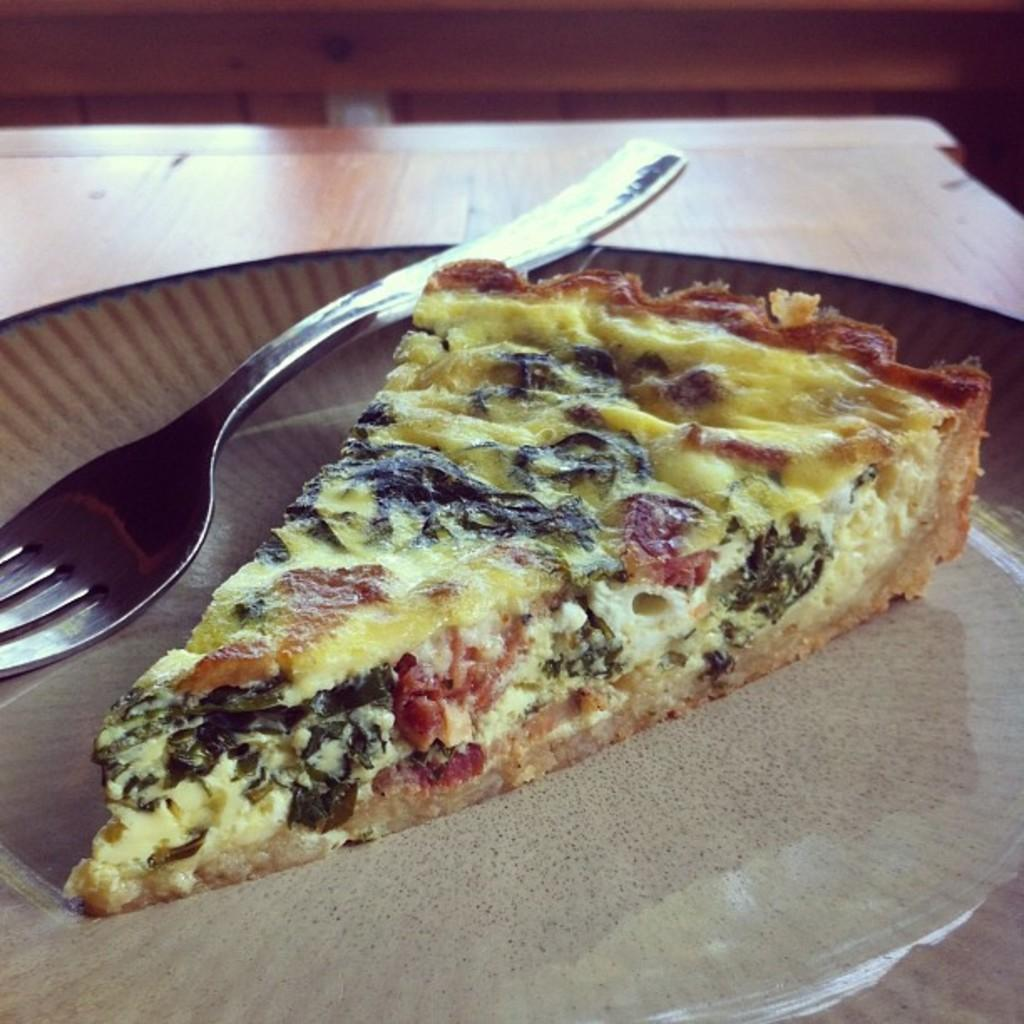What type of food is visible in the image? There is a slice of pizza in the image. What utensil can be seen on a plate in the image? There is a fork on a plate in the image. What type of society is depicted in the image? There is no society depicted in the image; it only shows a slice of pizza and a fork on a plate. How many clocks can be seen in the image? There are no clocks present in the image. 